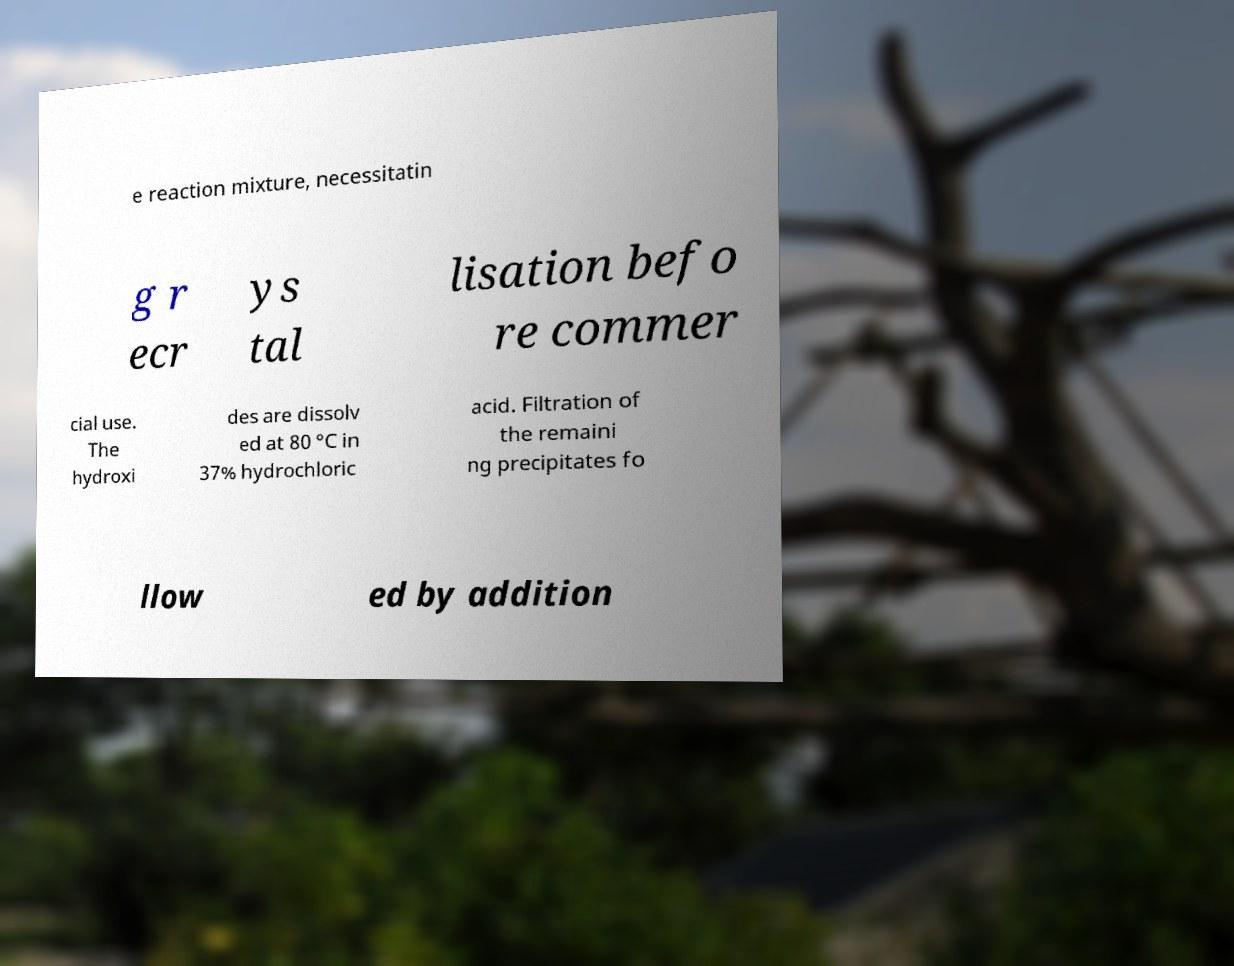Can you accurately transcribe the text from the provided image for me? e reaction mixture, necessitatin g r ecr ys tal lisation befo re commer cial use. The hydroxi des are dissolv ed at 80 °C in 37% hydrochloric acid. Filtration of the remaini ng precipitates fo llow ed by addition 